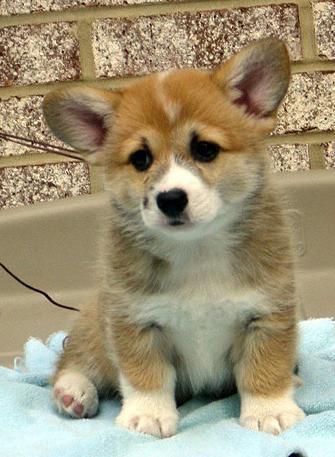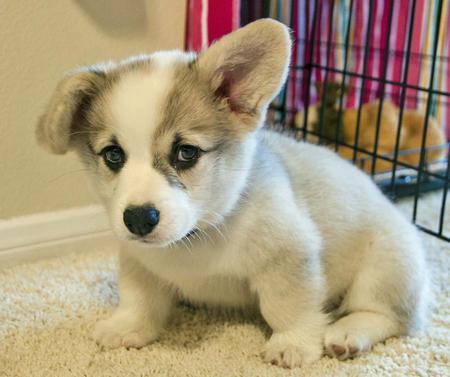The first image is the image on the left, the second image is the image on the right. For the images shown, is this caption "An image includes a corgi pup with one ear upright and the ear on the left flopping forward." true? Answer yes or no. Yes. The first image is the image on the left, the second image is the image on the right. Given the left and right images, does the statement "There's exactly two dogs in the left image." hold true? Answer yes or no. No. 